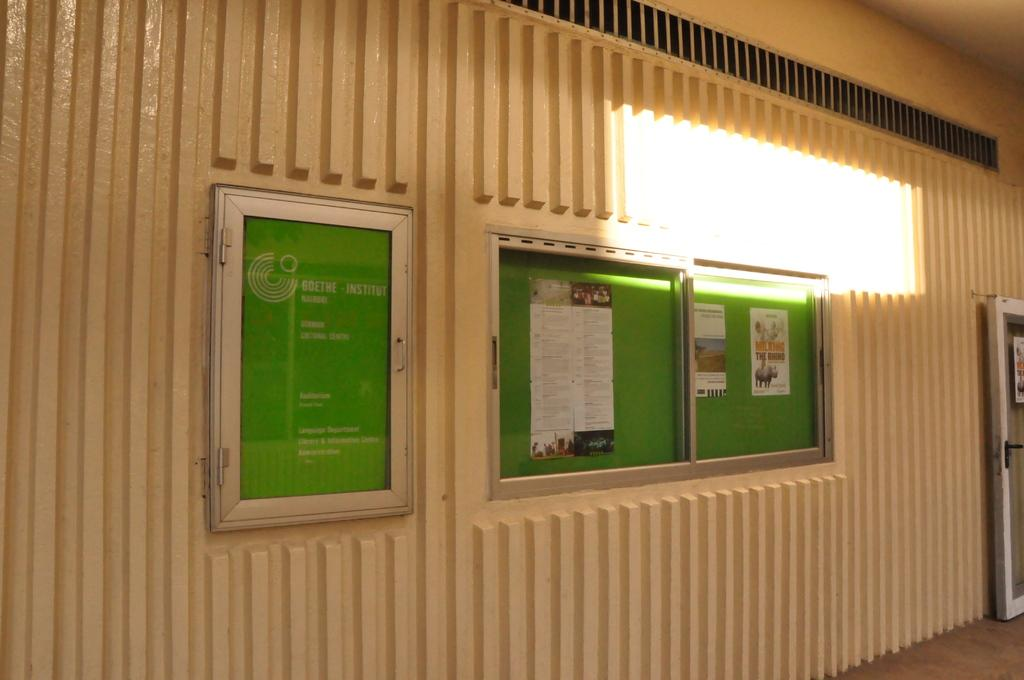What type of boards are present in the image? There are green color notice boards in the image. What can be seen on the right side of the image? There are lights on the right side of the image. What color is the wall in the background of the image? The wall in the background of the image is in cream color. Where is the goose taking a vacation in the image? There is no goose or any reference to a vacation in the image. 